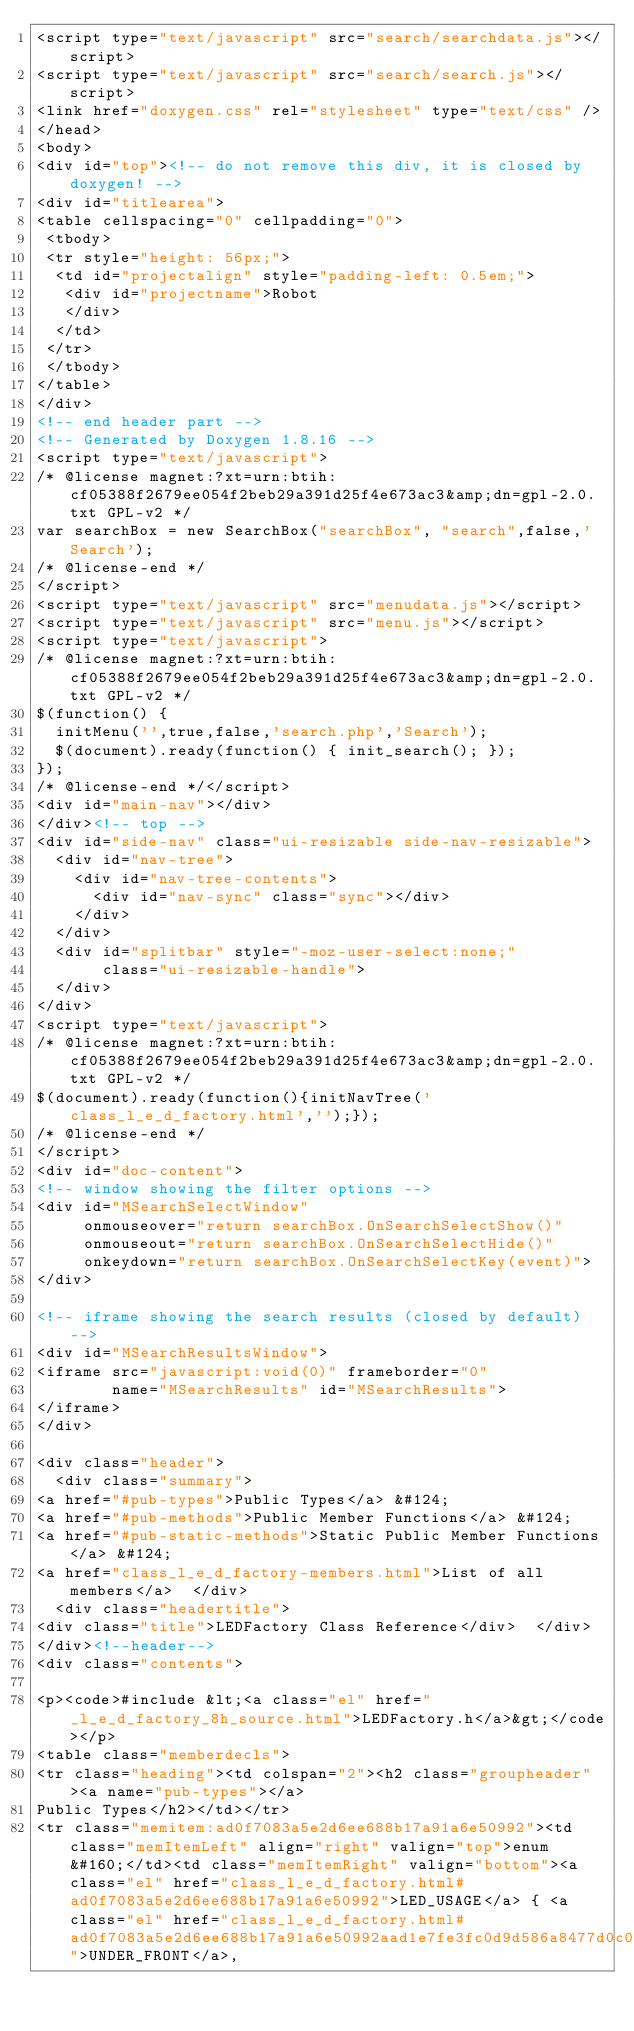<code> <loc_0><loc_0><loc_500><loc_500><_HTML_><script type="text/javascript" src="search/searchdata.js"></script>
<script type="text/javascript" src="search/search.js"></script>
<link href="doxygen.css" rel="stylesheet" type="text/css" />
</head>
<body>
<div id="top"><!-- do not remove this div, it is closed by doxygen! -->
<div id="titlearea">
<table cellspacing="0" cellpadding="0">
 <tbody>
 <tr style="height: 56px;">
  <td id="projectalign" style="padding-left: 0.5em;">
   <div id="projectname">Robot
   </div>
  </td>
 </tr>
 </tbody>
</table>
</div>
<!-- end header part -->
<!-- Generated by Doxygen 1.8.16 -->
<script type="text/javascript">
/* @license magnet:?xt=urn:btih:cf05388f2679ee054f2beb29a391d25f4e673ac3&amp;dn=gpl-2.0.txt GPL-v2 */
var searchBox = new SearchBox("searchBox", "search",false,'Search');
/* @license-end */
</script>
<script type="text/javascript" src="menudata.js"></script>
<script type="text/javascript" src="menu.js"></script>
<script type="text/javascript">
/* @license magnet:?xt=urn:btih:cf05388f2679ee054f2beb29a391d25f4e673ac3&amp;dn=gpl-2.0.txt GPL-v2 */
$(function() {
  initMenu('',true,false,'search.php','Search');
  $(document).ready(function() { init_search(); });
});
/* @license-end */</script>
<div id="main-nav"></div>
</div><!-- top -->
<div id="side-nav" class="ui-resizable side-nav-resizable">
  <div id="nav-tree">
    <div id="nav-tree-contents">
      <div id="nav-sync" class="sync"></div>
    </div>
  </div>
  <div id="splitbar" style="-moz-user-select:none;" 
       class="ui-resizable-handle">
  </div>
</div>
<script type="text/javascript">
/* @license magnet:?xt=urn:btih:cf05388f2679ee054f2beb29a391d25f4e673ac3&amp;dn=gpl-2.0.txt GPL-v2 */
$(document).ready(function(){initNavTree('class_l_e_d_factory.html','');});
/* @license-end */
</script>
<div id="doc-content">
<!-- window showing the filter options -->
<div id="MSearchSelectWindow"
     onmouseover="return searchBox.OnSearchSelectShow()"
     onmouseout="return searchBox.OnSearchSelectHide()"
     onkeydown="return searchBox.OnSearchSelectKey(event)">
</div>

<!-- iframe showing the search results (closed by default) -->
<div id="MSearchResultsWindow">
<iframe src="javascript:void(0)" frameborder="0" 
        name="MSearchResults" id="MSearchResults">
</iframe>
</div>

<div class="header">
  <div class="summary">
<a href="#pub-types">Public Types</a> &#124;
<a href="#pub-methods">Public Member Functions</a> &#124;
<a href="#pub-static-methods">Static Public Member Functions</a> &#124;
<a href="class_l_e_d_factory-members.html">List of all members</a>  </div>
  <div class="headertitle">
<div class="title">LEDFactory Class Reference</div>  </div>
</div><!--header-->
<div class="contents">

<p><code>#include &lt;<a class="el" href="_l_e_d_factory_8h_source.html">LEDFactory.h</a>&gt;</code></p>
<table class="memberdecls">
<tr class="heading"><td colspan="2"><h2 class="groupheader"><a name="pub-types"></a>
Public Types</h2></td></tr>
<tr class="memitem:ad0f7083a5e2d6ee688b17a91a6e50992"><td class="memItemLeft" align="right" valign="top">enum &#160;</td><td class="memItemRight" valign="bottom"><a class="el" href="class_l_e_d_factory.html#ad0f7083a5e2d6ee688b17a91a6e50992">LED_USAGE</a> { <a class="el" href="class_l_e_d_factory.html#ad0f7083a5e2d6ee688b17a91a6e50992aad1e7fe3fc0d9d586a8477d0c02ea0c3">UNDER_FRONT</a>, </code> 